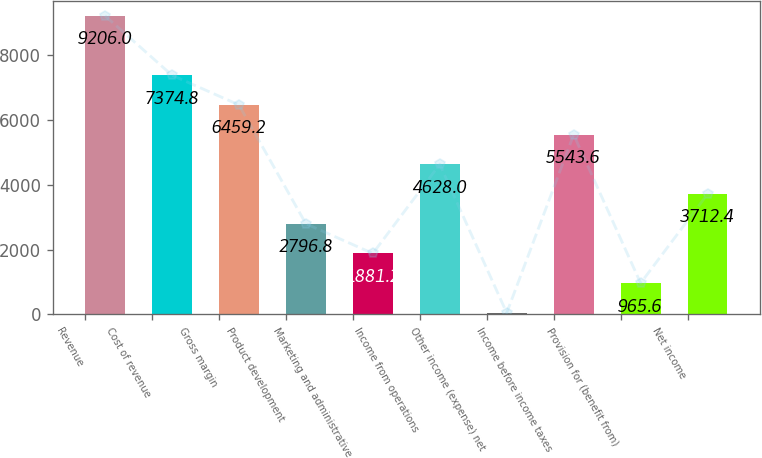<chart> <loc_0><loc_0><loc_500><loc_500><bar_chart><fcel>Revenue<fcel>Cost of revenue<fcel>Gross margin<fcel>Product development<fcel>Marketing and administrative<fcel>Income from operations<fcel>Other income (expense) net<fcel>Income before income taxes<fcel>Provision for (benefit from)<fcel>Net income<nl><fcel>9206<fcel>7374.8<fcel>6459.2<fcel>2796.8<fcel>1881.2<fcel>4628<fcel>50<fcel>5543.6<fcel>965.6<fcel>3712.4<nl></chart> 